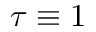Convert formula to latex. <formula><loc_0><loc_0><loc_500><loc_500>\tau \equiv 1</formula> 